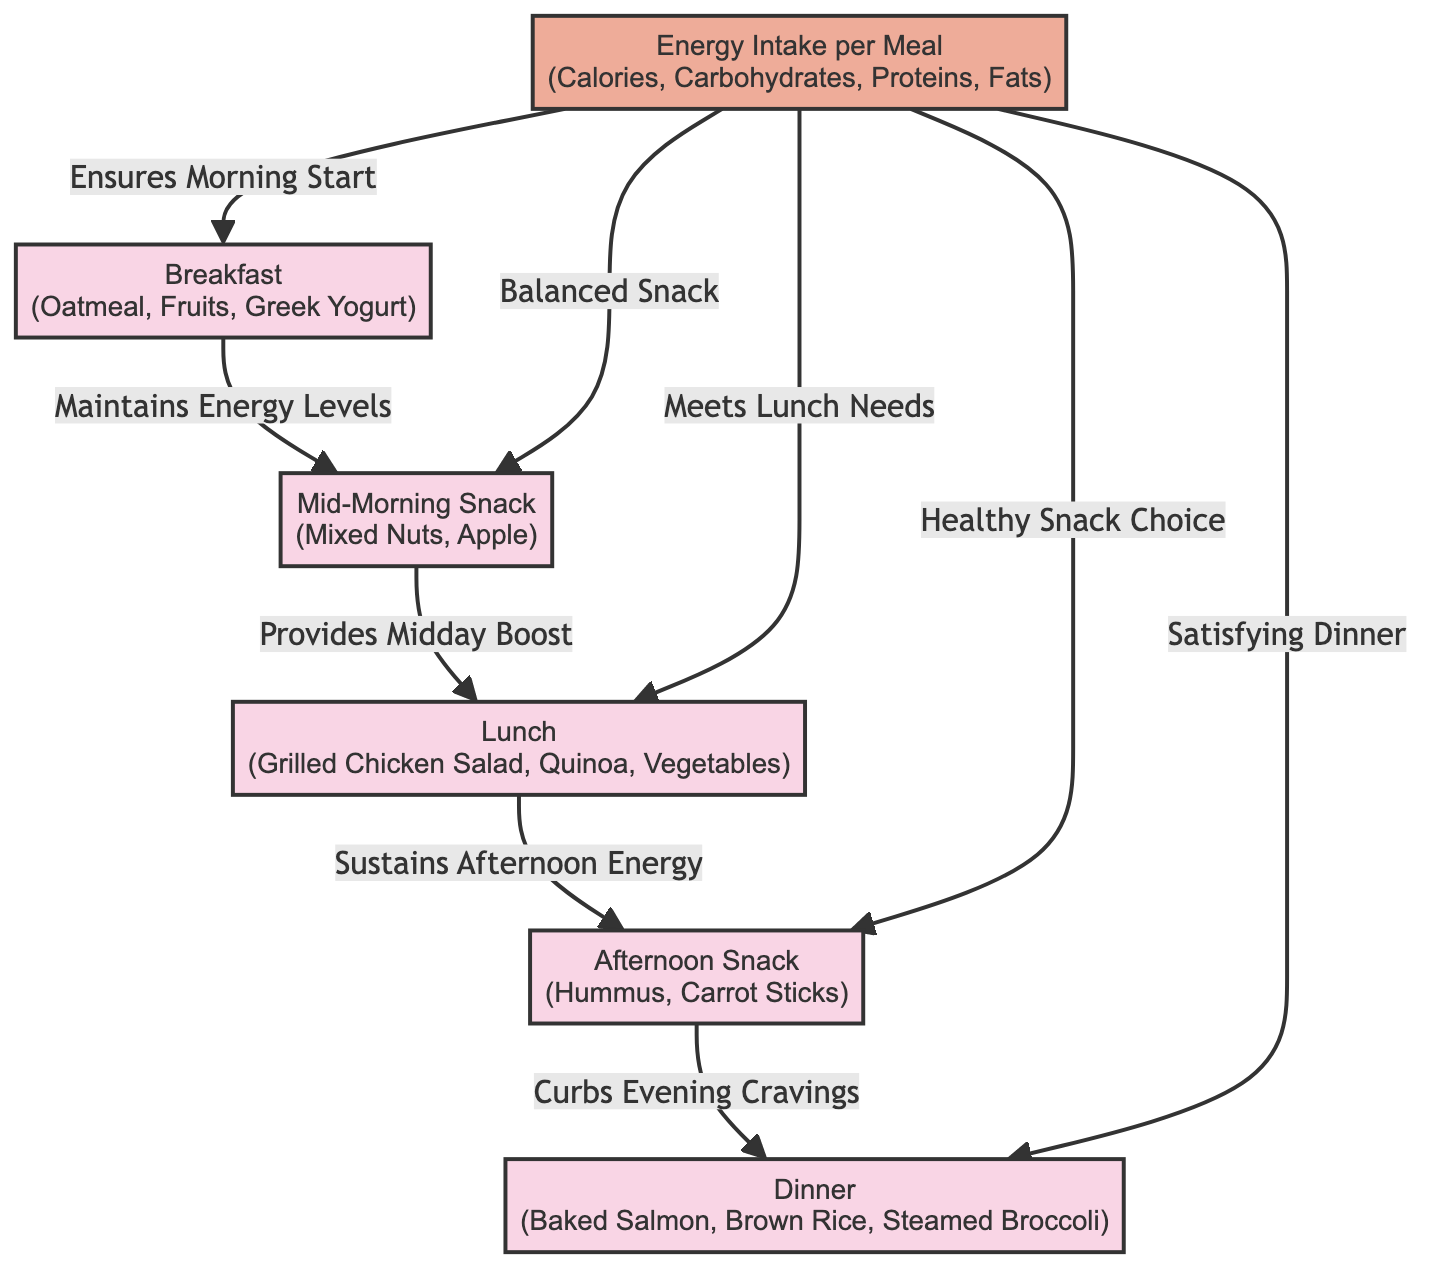What is the first meal in the diagram? The first meal node in the diagram is connected directly to the energy intake node and has no preceding nodes, indicating it is the starting point. Therefore, it is Breakfast.
Answer: Breakfast What meal follows the mid-morning snack? The mid-morning snack connects to the lunch node, indicating that it is the meal that comes after the mid-morning snack.
Answer: Lunch How many snacks are in the diagram? There are two snack nodes: Mid-Morning Snack and Afternoon Snack, which can be counted directly from the diagram's meal nodes.
Answer: 2 What meal is associated with curbing evening cravings? The afternoon snack node is directly connected to the dinner node with the labeled edge "Curbs Evening Cravings," indicating its relationship.
Answer: Dinner What does energy intake ensure at breakfast? The edge connecting the energy intake node to the breakfast node states "Ensures Morning Start," indicating the effect or assurance provided by energy intake at breakfast.
Answer: Morning Start Which meal provides a midday boost? According to the diagram, the mid-morning snack is directly connected to lunch and labeled "Provides Midday Boost," which defines its role in this context.
Answer: Lunch What food choice is highlighted for the afternoon snack? The energy intake node has an edge labeled "Healthy Snack Choice" leading to the afternoon snack, making this the prominent food choice described.
Answer: Healthy Snack Choice How does lunch affect afternoon energy? Lunch directly connects to the afternoon snack node with "Sustains Afternoon Energy," which indicates its role in maintaining energy levels into the afternoon.
Answer: Sustains Afternoon Energy What is the last meal represented in the diagram? The final node, which is not followed by any other nodes and connects back to energy intake, indicates that it is the last in the sequence. Thus, it is Dinner.
Answer: Dinner 